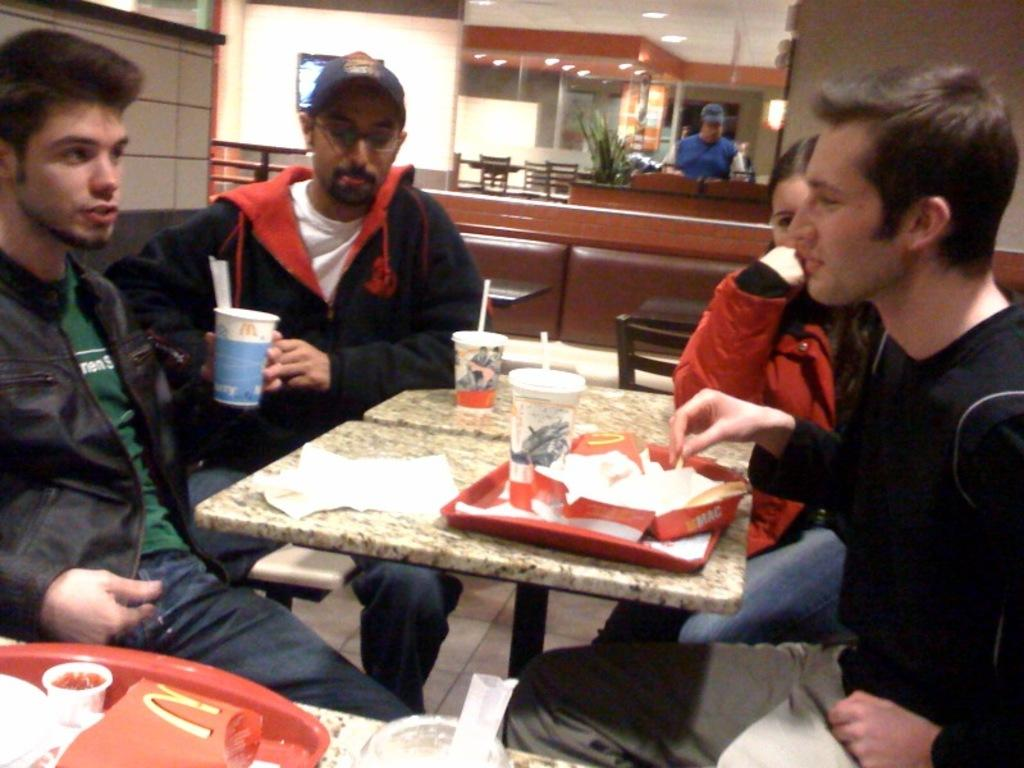How many people are present in the image? There are four people in the image. What are the people doing in the image? The people are sitting around a table. What can be seen on the table in the image? There are many food items on the table. What color is the daughter's hair in the image? There is no mention of a daughter in the image, so we cannot answer this question. 